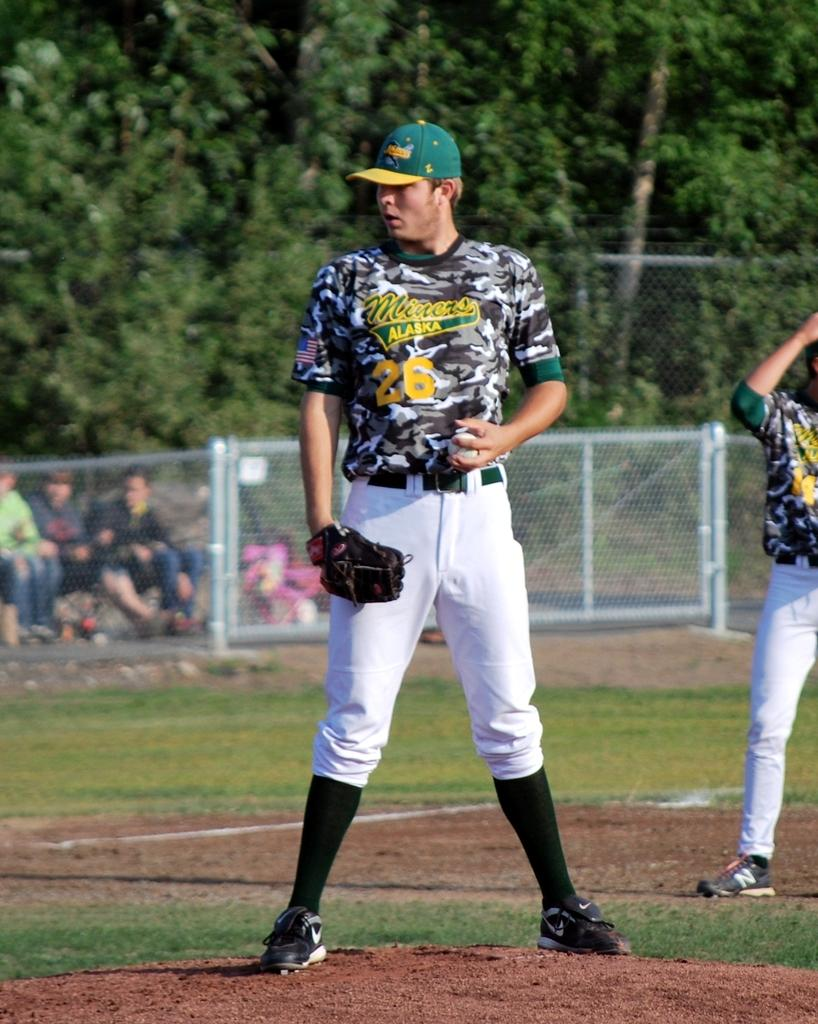<image>
Describe the image concisely. A player from the Miners baseball team in Alaska stands on the field's mound. 